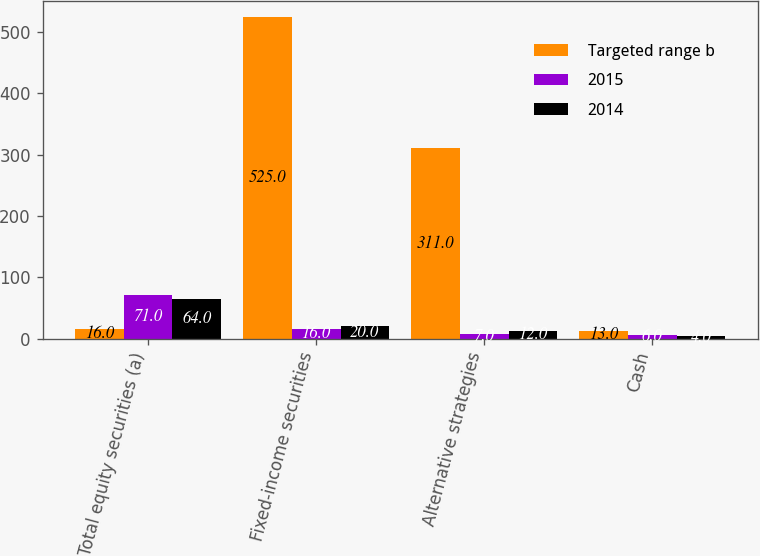Convert chart. <chart><loc_0><loc_0><loc_500><loc_500><stacked_bar_chart><ecel><fcel>Total equity securities (a)<fcel>Fixed-income securities<fcel>Alternative strategies<fcel>Cash<nl><fcel>Targeted range b<fcel>16<fcel>525<fcel>311<fcel>13<nl><fcel>2015<fcel>71<fcel>16<fcel>7<fcel>6<nl><fcel>2014<fcel>64<fcel>20<fcel>12<fcel>4<nl></chart> 